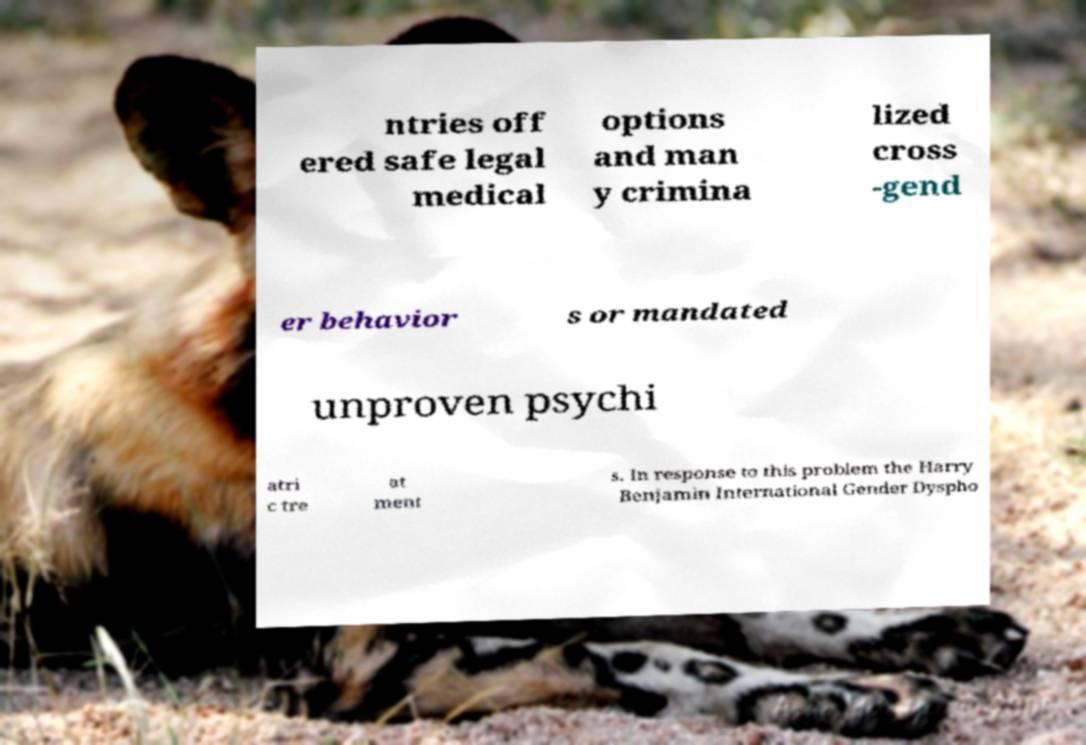What messages or text are displayed in this image? I need them in a readable, typed format. ntries off ered safe legal medical options and man y crimina lized cross -gend er behavior s or mandated unproven psychi atri c tre at ment s. In response to this problem the Harry Benjamin International Gender Dyspho 